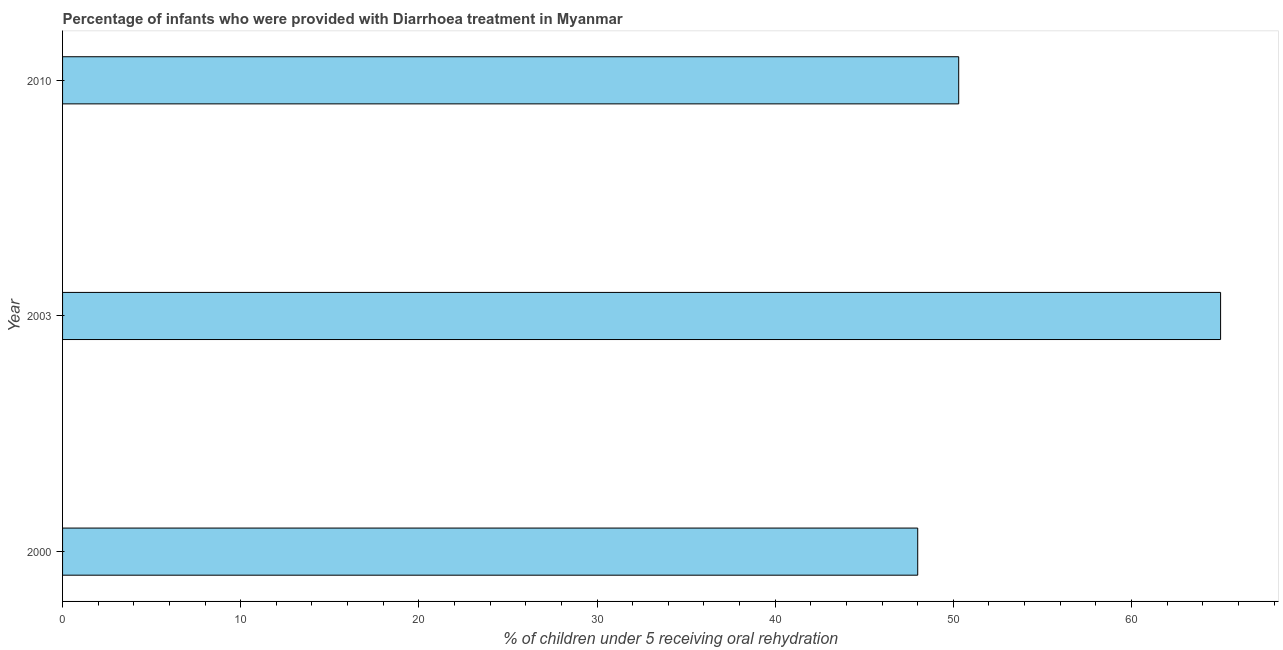Does the graph contain any zero values?
Keep it short and to the point. No. Does the graph contain grids?
Your response must be concise. No. What is the title of the graph?
Ensure brevity in your answer.  Percentage of infants who were provided with Diarrhoea treatment in Myanmar. What is the label or title of the X-axis?
Make the answer very short. % of children under 5 receiving oral rehydration. What is the percentage of children who were provided with treatment diarrhoea in 2010?
Your answer should be compact. 50.3. Across all years, what is the maximum percentage of children who were provided with treatment diarrhoea?
Make the answer very short. 65. In which year was the percentage of children who were provided with treatment diarrhoea maximum?
Give a very brief answer. 2003. What is the sum of the percentage of children who were provided with treatment diarrhoea?
Keep it short and to the point. 163.3. What is the average percentage of children who were provided with treatment diarrhoea per year?
Your answer should be compact. 54.43. What is the median percentage of children who were provided with treatment diarrhoea?
Give a very brief answer. 50.3. What is the ratio of the percentage of children who were provided with treatment diarrhoea in 2000 to that in 2010?
Your response must be concise. 0.95. Is the percentage of children who were provided with treatment diarrhoea in 2003 less than that in 2010?
Keep it short and to the point. No. What is the difference between the highest and the second highest percentage of children who were provided with treatment diarrhoea?
Your answer should be very brief. 14.7. How many bars are there?
Provide a succinct answer. 3. Are all the bars in the graph horizontal?
Provide a succinct answer. Yes. Are the values on the major ticks of X-axis written in scientific E-notation?
Your answer should be very brief. No. What is the % of children under 5 receiving oral rehydration of 2003?
Provide a short and direct response. 65. What is the % of children under 5 receiving oral rehydration in 2010?
Give a very brief answer. 50.3. What is the difference between the % of children under 5 receiving oral rehydration in 2000 and 2003?
Offer a terse response. -17. What is the ratio of the % of children under 5 receiving oral rehydration in 2000 to that in 2003?
Give a very brief answer. 0.74. What is the ratio of the % of children under 5 receiving oral rehydration in 2000 to that in 2010?
Provide a succinct answer. 0.95. What is the ratio of the % of children under 5 receiving oral rehydration in 2003 to that in 2010?
Make the answer very short. 1.29. 